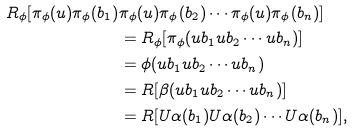<formula> <loc_0><loc_0><loc_500><loc_500>R _ { \phi } [ \pi _ { \phi } ( u ) \pi _ { \phi } ( b _ { 1 } ) & \pi _ { \phi } ( u ) \pi _ { \phi } ( b _ { 2 } ) \cdots \pi _ { \phi } ( u ) \pi _ { \phi } ( b _ { n } ) ] \\ & = R _ { \phi } [ \pi _ { \phi } ( u b _ { 1 } u b _ { 2 } \cdots u b _ { n } ) ] \\ & = \phi ( u b _ { 1 } u b _ { 2 } \cdots u b _ { n } ) \\ & = R [ \beta ( u b _ { 1 } u b _ { 2 } \cdots u b _ { n } ) ] \\ & = R [ U \alpha ( b _ { 1 } ) U \alpha ( b _ { 2 } ) \cdots U \alpha ( b _ { n } ) ] ,</formula> 